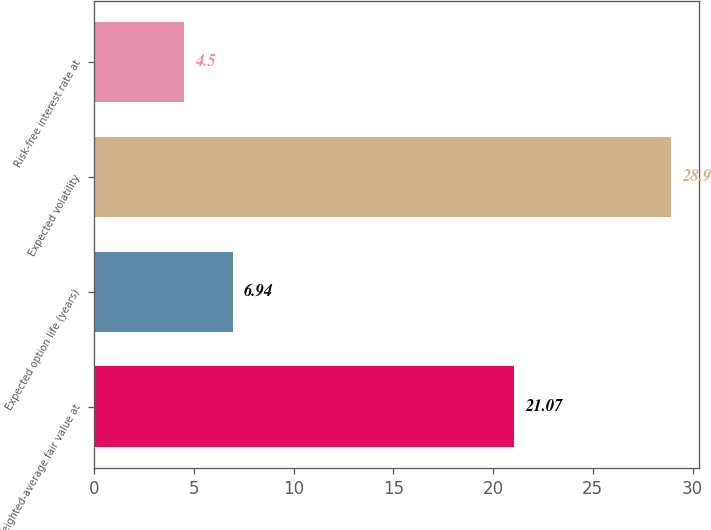<chart> <loc_0><loc_0><loc_500><loc_500><bar_chart><fcel>Weighted-average fair value at<fcel>Expected option life (years)<fcel>Expected volatility<fcel>Risk-free interest rate at<nl><fcel>21.07<fcel>6.94<fcel>28.9<fcel>4.5<nl></chart> 